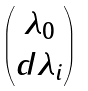<formula> <loc_0><loc_0><loc_500><loc_500>\begin{pmatrix} \lambda _ { 0 } \\ d \lambda _ { i } \end{pmatrix}</formula> 